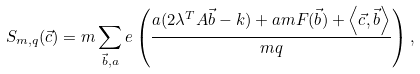<formula> <loc_0><loc_0><loc_500><loc_500>S _ { m , q } ( \vec { c } ) = m \sum _ { \vec { b } , a } e \left ( \frac { a ( 2 \lambda ^ { T } A \vec { b } - k ) + a m F ( \vec { b } ) + \left < \vec { c } , \vec { b } \right > } { m q } \right ) ,</formula> 